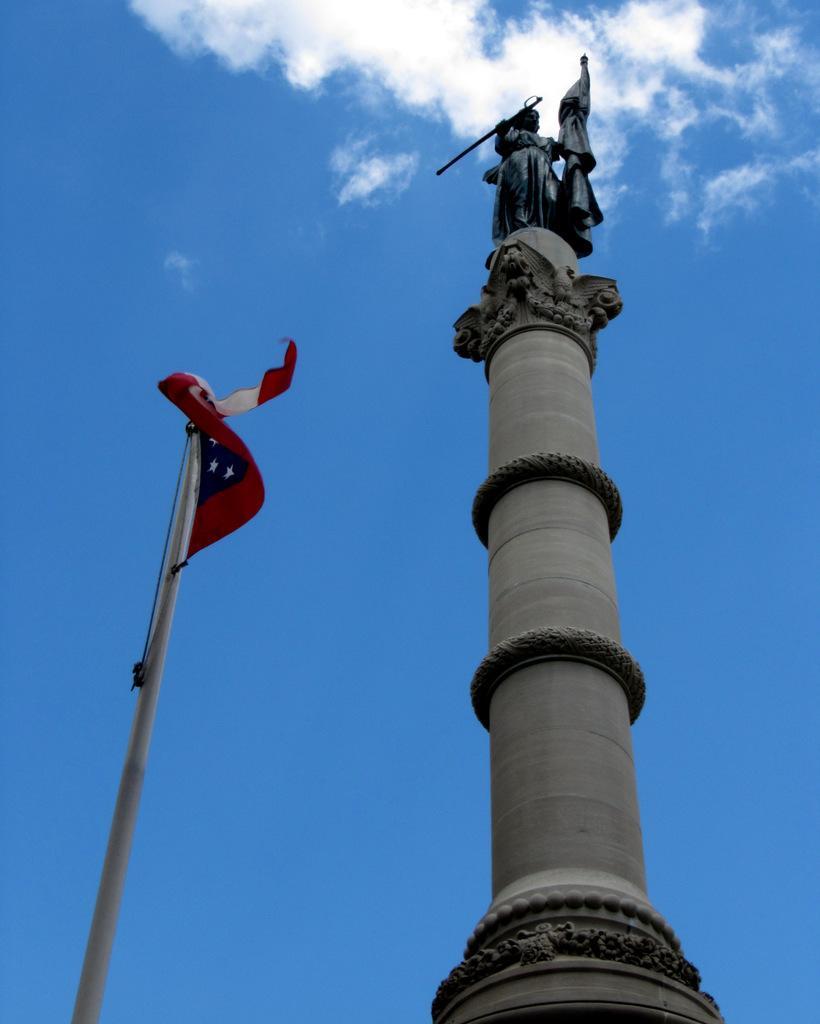Please provide a concise description of this image. In this image we can see a pillar and on the pillar we can see a sculpture. Beside the pillar we can see a pole with a flag. Behind the pillar we can see the clear sky. 